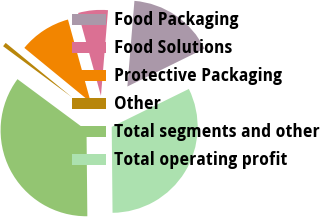Convert chart. <chart><loc_0><loc_0><loc_500><loc_500><pie_chart><fcel>Food Packaging<fcel>Food Solutions<fcel>Protective Packaging<fcel>Other<fcel>Total segments and other<fcel>Total operating profit<nl><fcel>16.42%<fcel>5.59%<fcel>9.79%<fcel>0.78%<fcel>35.3%<fcel>32.12%<nl></chart> 